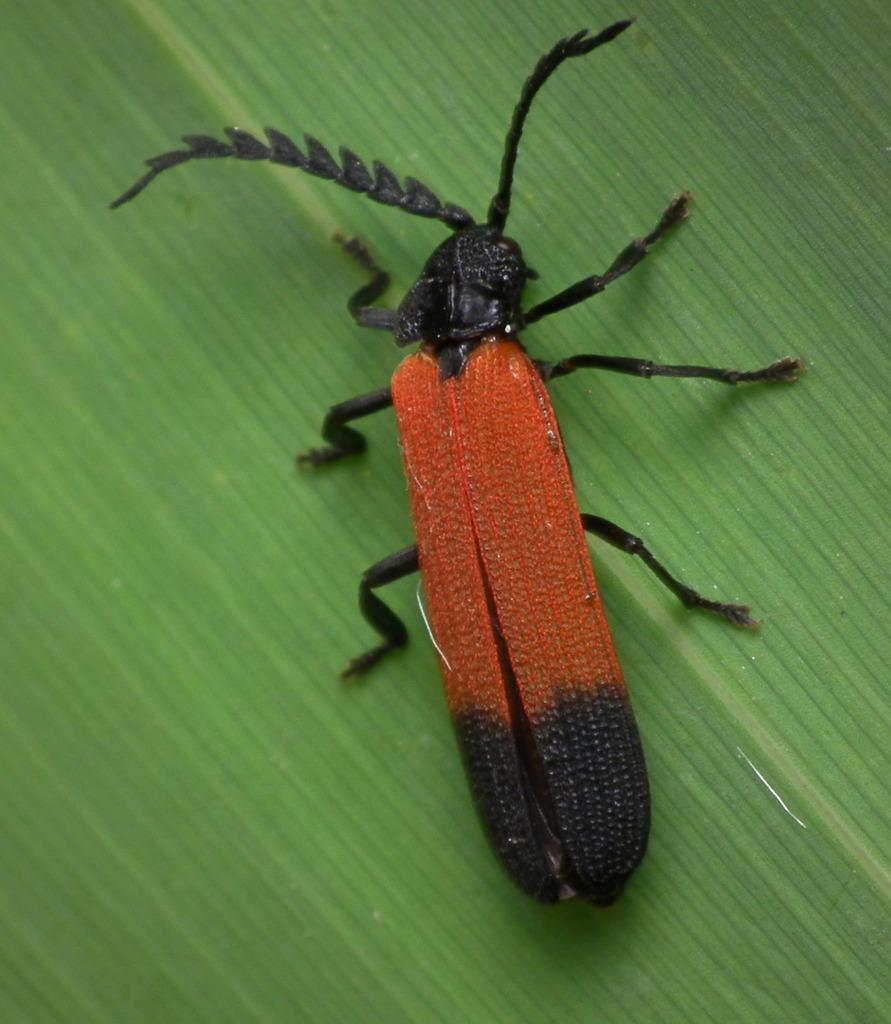What type of insect is in the picture? There is a Longhorn beetle in the picture. What is the beetle resting on? The beetle is on a greenery surface. What hobbies does the Longhorn beetle have in the picture? Insects do not have hobbies, so this question cannot be answered based on the information provided. 